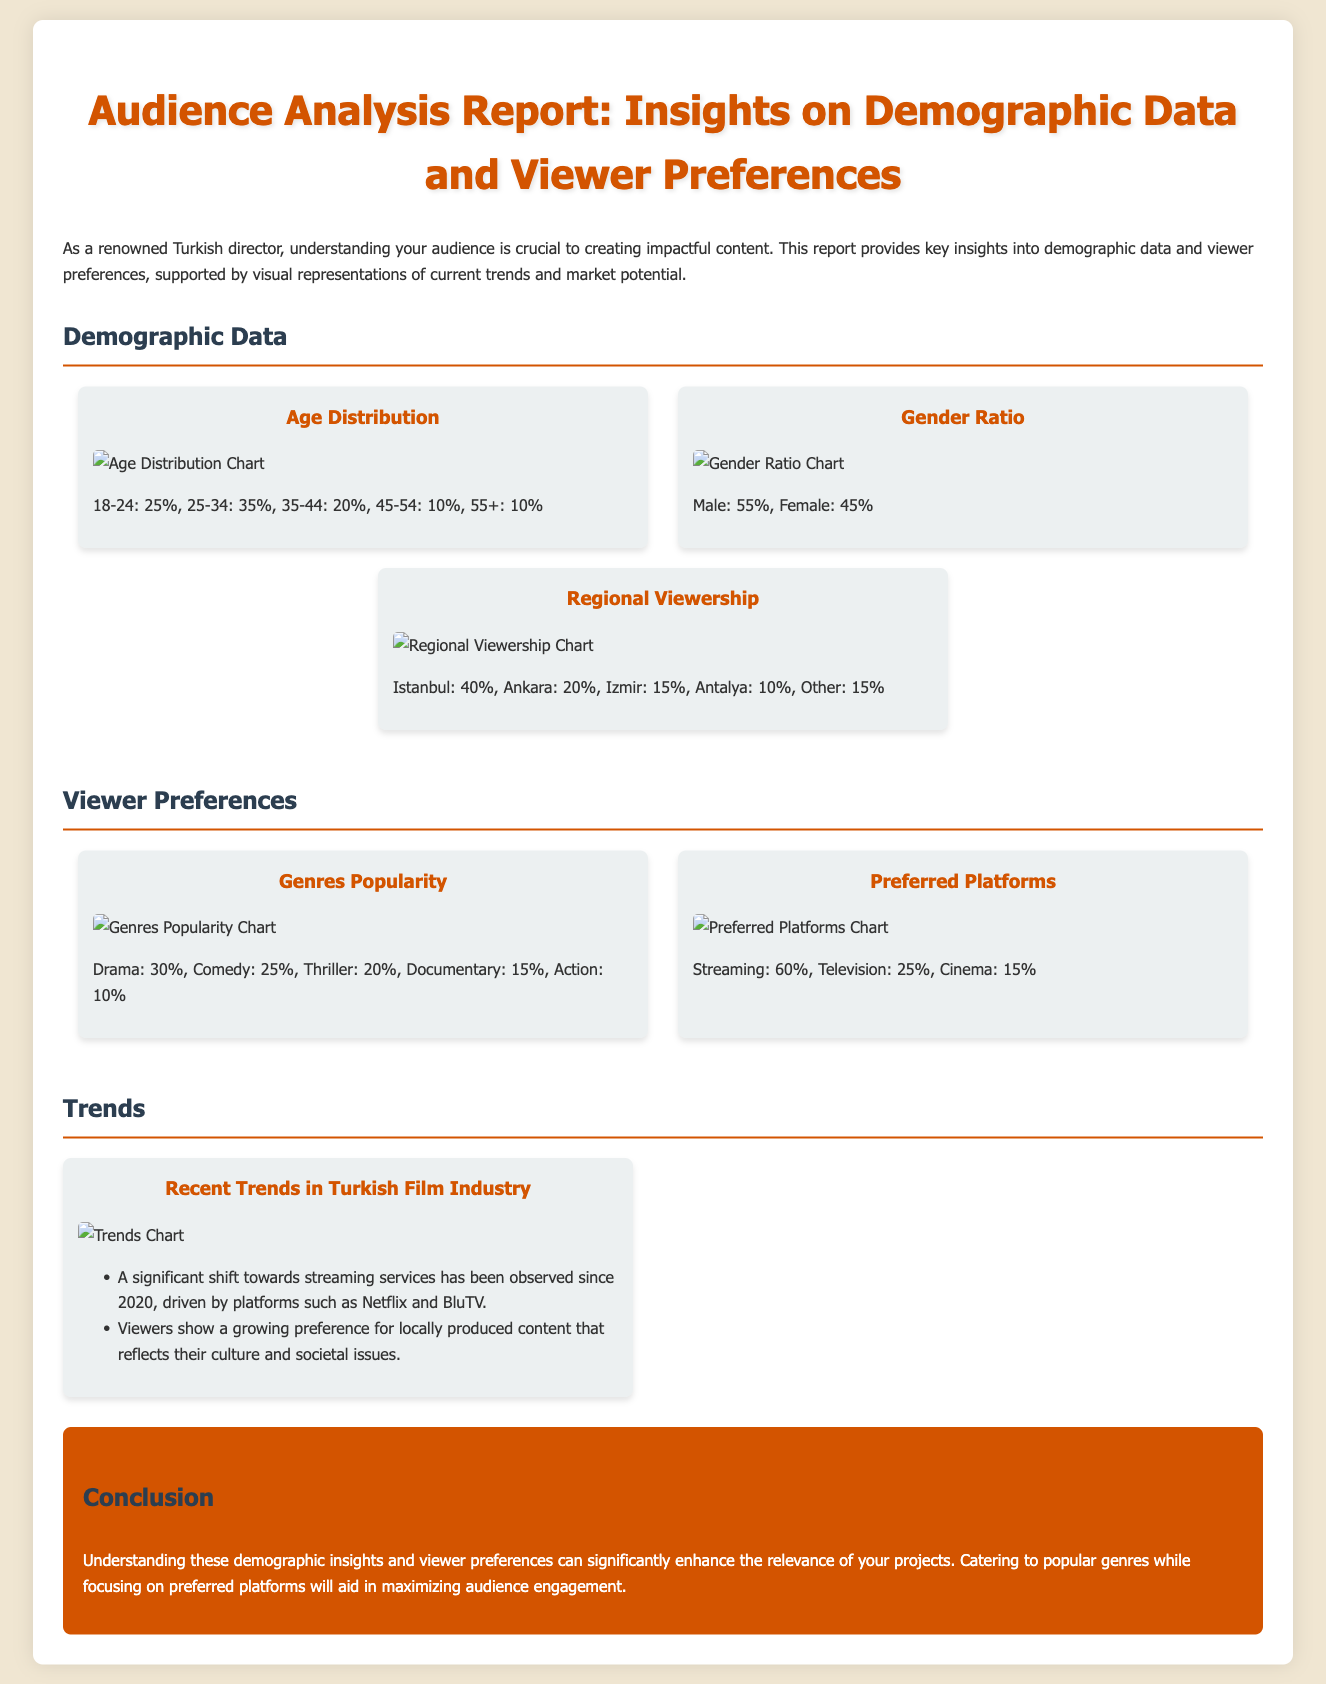what is the percentage of viewers aged 25-34? The percentage of viewers aged 25-34 is stated in the Age Distribution section as 35%.
Answer: 35% what is the gender ratio of the audience? The gender ratio is provided in the Gender Ratio section, indicating Male: 55%, Female: 45%.
Answer: Male: 55%, Female: 45% which genre is most popular among viewers? The Genres Popularity section indicates that Drama is the most popular genre.
Answer: Drama what percentage of viewership comes from Istanbul? The Regional Viewership section specifies that 40% of viewership comes from Istanbul.
Answer: 40% which platform do 60% of viewers prefer? The Preferred Platforms section shows that 60% of viewers prefer Streaming services.
Answer: Streaming what trend has been observed regarding viewers' preference for content since 2020? The Trends section mentions a significant shift towards streaming services since 2020.
Answer: Shift towards streaming services how much of the audience prefers television as a viewing platform? The Preferred Platforms section states that 25% of the audience prefers Television.
Answer: 25% what is the percentage of viewers who like Action genre? The Genres Popularity section specifies that 10% of viewers like the Action genre.
Answer: 10% what conclusion is drawn about audience engagement? The Conclusion section states that catering to popular genres while focusing on preferred platforms will aid in maximizing audience engagement.
Answer: Maximize audience engagement 